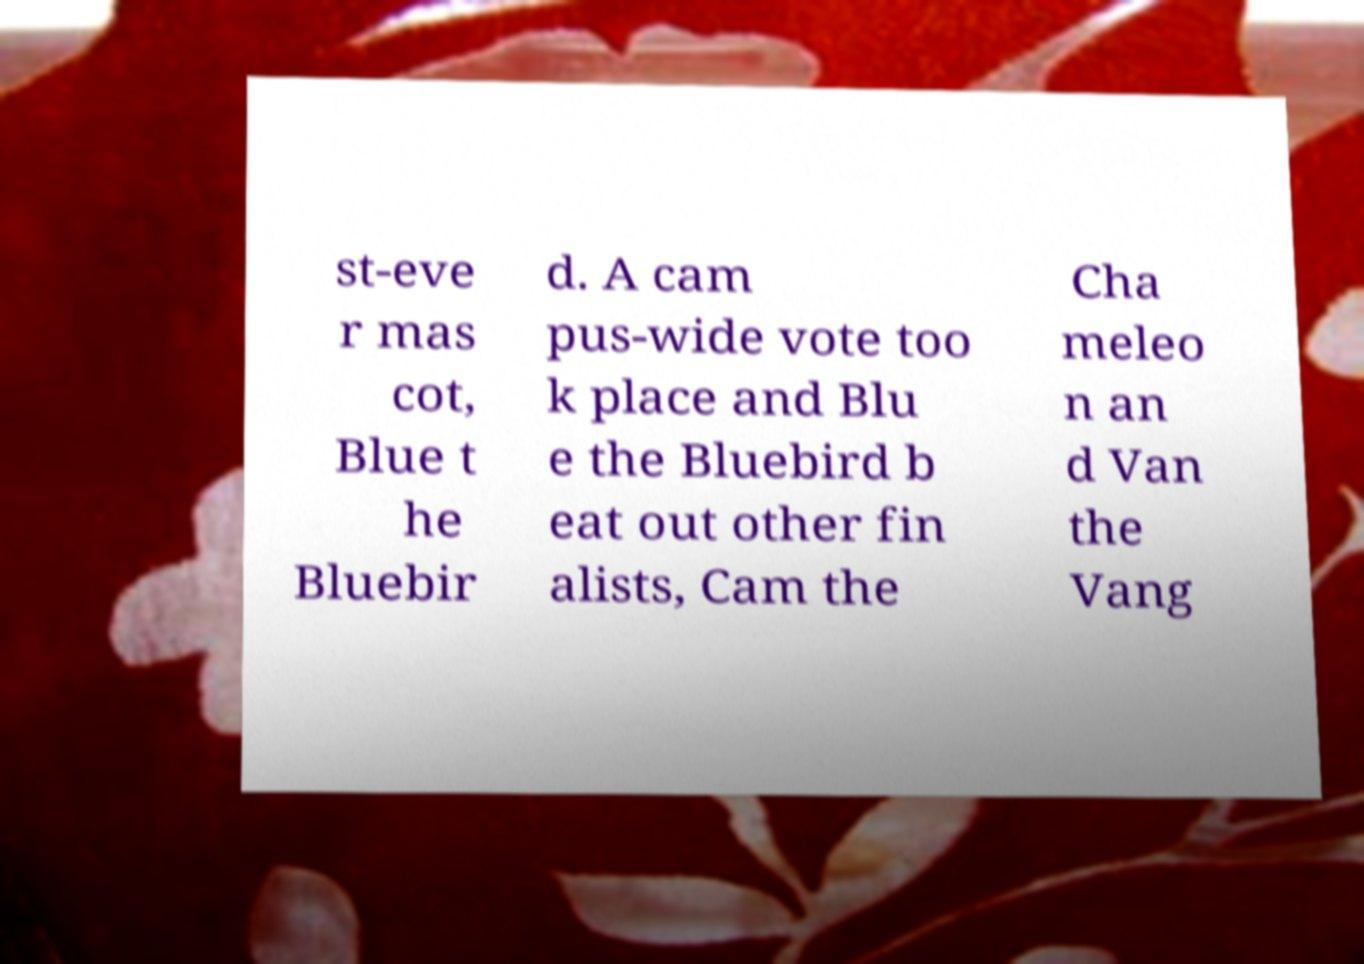Please read and relay the text visible in this image. What does it say? st-eve r mas cot, Blue t he Bluebir d. A cam pus-wide vote too k place and Blu e the Bluebird b eat out other fin alists, Cam the Cha meleo n an d Van the Vang 